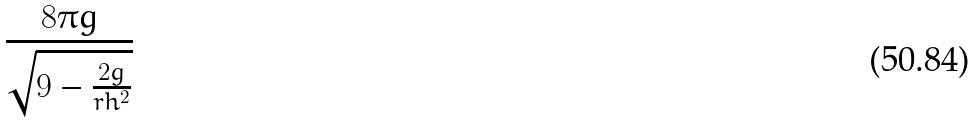Convert formula to latex. <formula><loc_0><loc_0><loc_500><loc_500>\frac { 8 \pi g } { \sqrt { 9 - \frac { 2 g } { r h ^ { 2 } } } }</formula> 